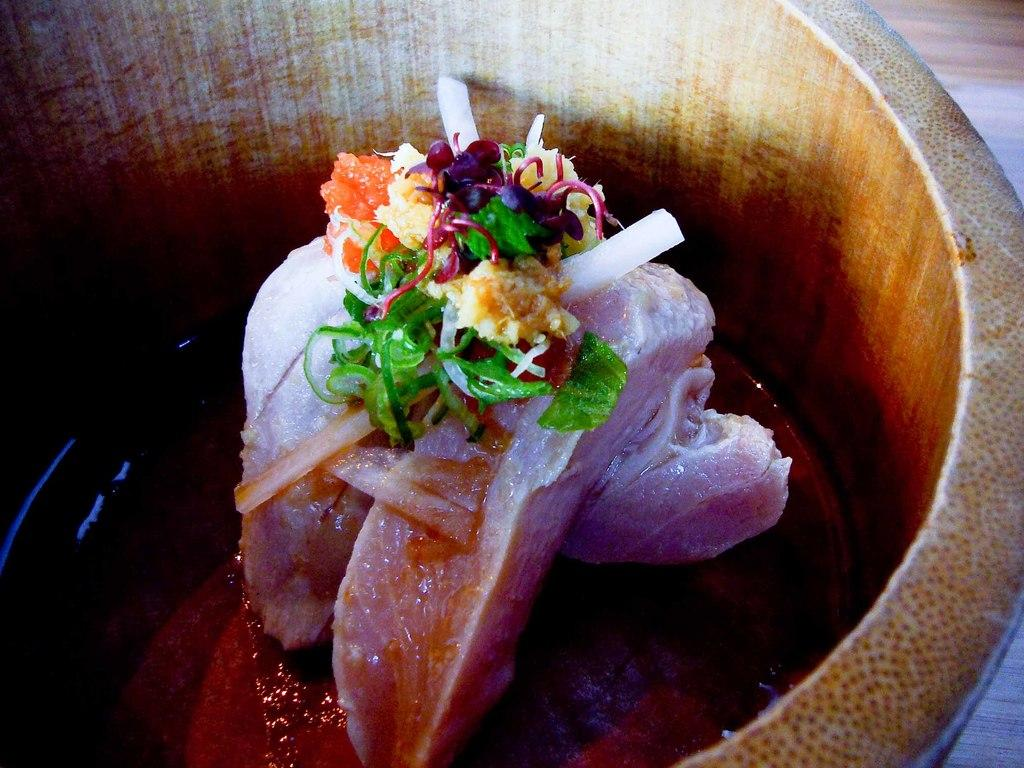What type of bowl is in the image? There is a wooden bowl in the image. What is inside the wooden bowl? There is a food item in the wooden bowl. What color is the sock that is being heated in the image? There is no sock or heat source present in the image; it only features a wooden bowl with a food item. 